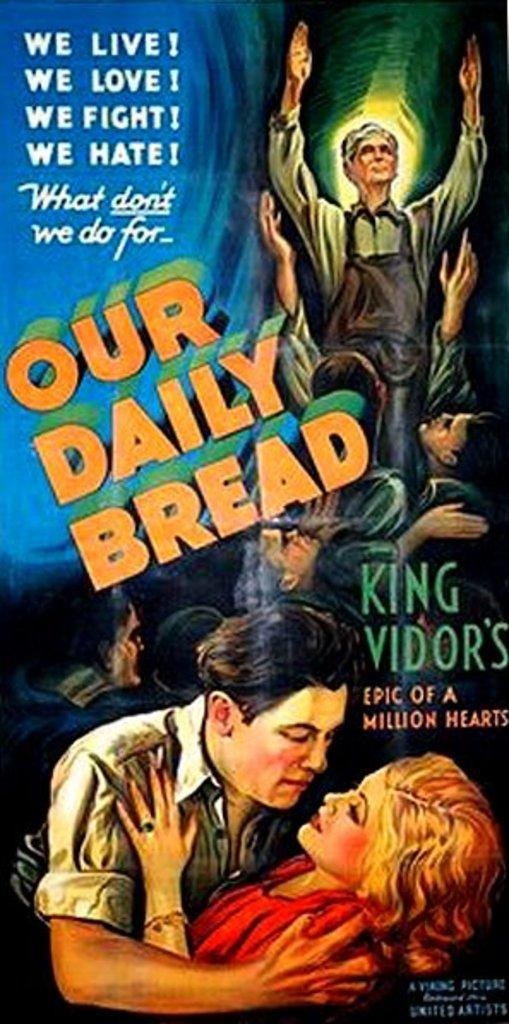<image>
Provide a brief description of the given image. A movie postor for Our Daily Bread shows a woman in a man's arms. 